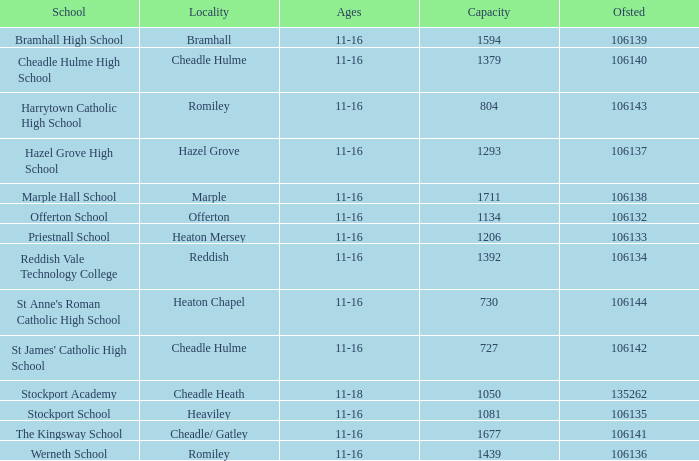Which School has a Capacity larger than 730, and an Ofsted smaller than 106135, and a Locality of heaton mersey? Priestnall School. 